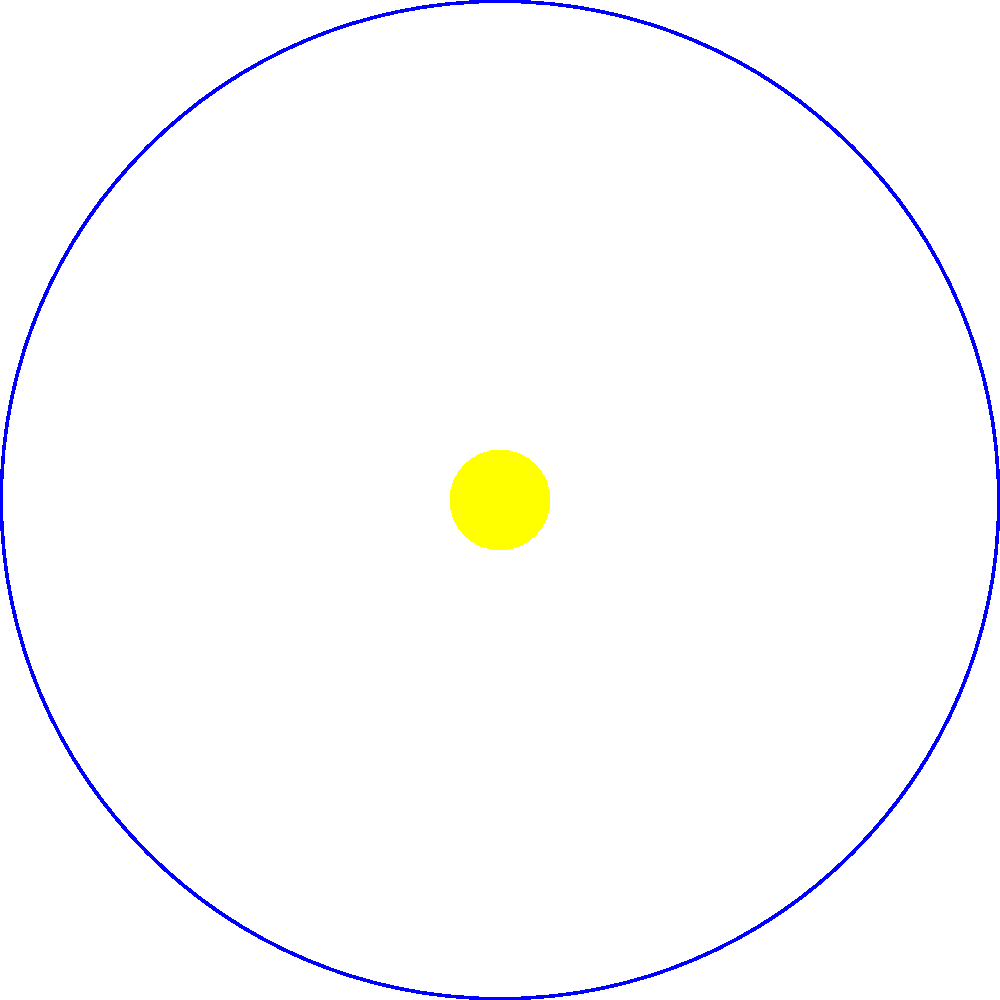Consider the diagram showing the orbits of Earth and a comet around the Sun. Given that the comet's orbital period is 76 years and its perihelion (closest approach to the Sun) occurs every January 1st, how many times would a literature professor born in 1960 expect to see this comet in their lifetime, assuming an average life expectancy of 80 years? To solve this problem, we need to follow these steps:

1. Determine the years when the comet is visible:
   The comet appears at perihelion every 76 years.
   Starting from 1960, the appearances would be in:
   1960 + 76 = 2036
   2036 + 76 = 2112 (beyond the professor's lifetime)

2. Calculate the professor's age at each appearance:
   1960: 0 years old (birth year)
   2036: 76 years old

3. Compare with the professor's expected lifetime:
   The professor's expected lifetime is 80 years, ending in 2040.

4. Count the number of appearances within the lifetime:
   1960: Visible (assuming it can be seen by a newborn)
   2036: Visible (at age 76)

Therefore, the professor would expect to see the comet twice in their lifetime.

Note: This calculation assumes that the comet is visible from Earth at each perihelion passage and that atmospheric conditions and the professor's location allow for observation.
Answer: Twice 